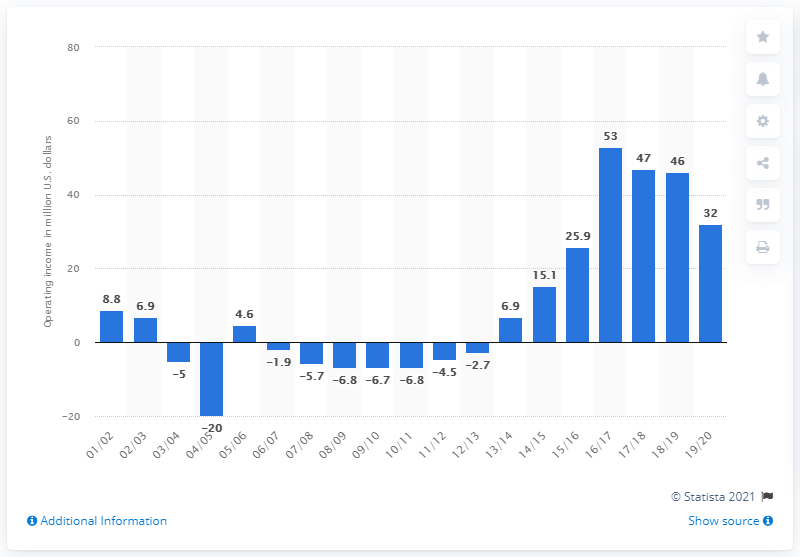Mention a couple of crucial points in this snapshot. The operating income of the Minnesota Timberwolves in the 2019/20 season was $32 million. 